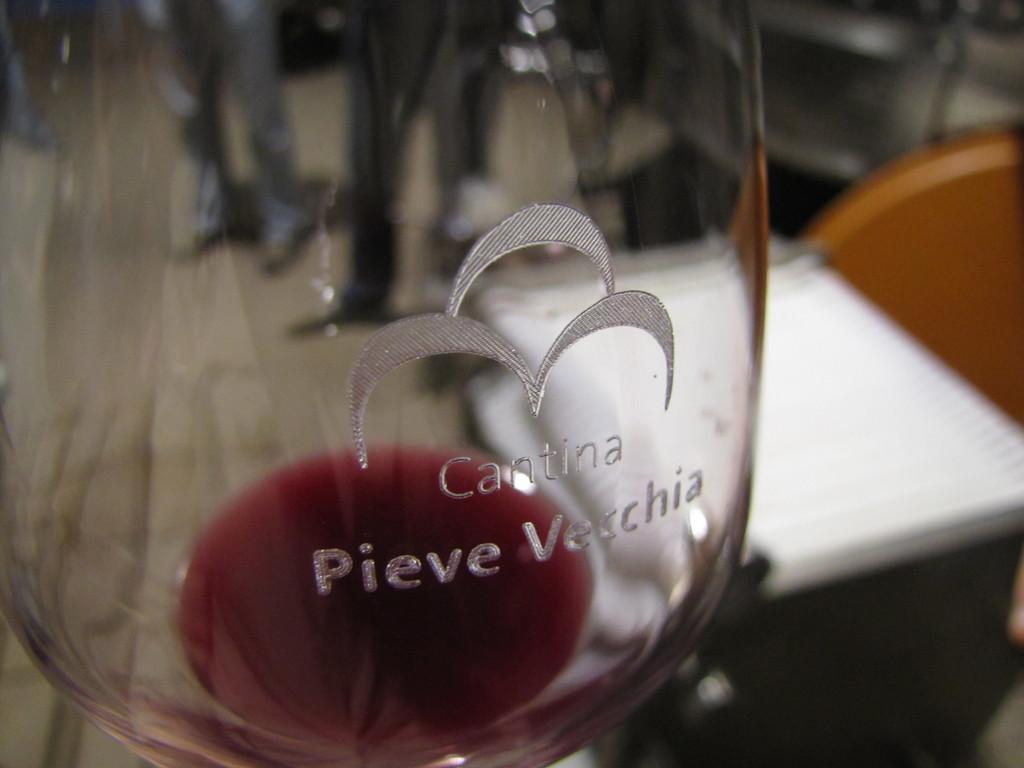What brand of wine?
Give a very brief answer. Pieve vecchia. What is written on the glass?
Offer a terse response. Cantina pieve vecchia. 